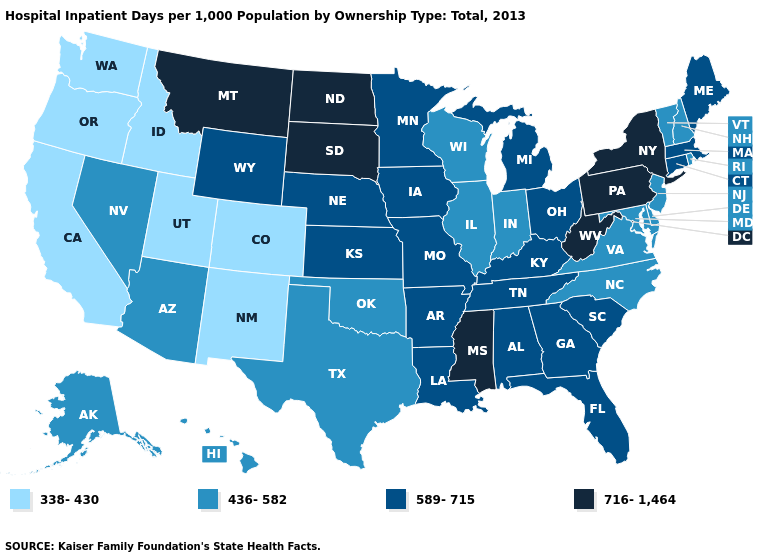Name the states that have a value in the range 716-1,464?
Answer briefly. Mississippi, Montana, New York, North Dakota, Pennsylvania, South Dakota, West Virginia. Name the states that have a value in the range 716-1,464?
Keep it brief. Mississippi, Montana, New York, North Dakota, Pennsylvania, South Dakota, West Virginia. Which states have the lowest value in the USA?
Concise answer only. California, Colorado, Idaho, New Mexico, Oregon, Utah, Washington. Does Texas have the highest value in the South?
Answer briefly. No. Name the states that have a value in the range 589-715?
Keep it brief. Alabama, Arkansas, Connecticut, Florida, Georgia, Iowa, Kansas, Kentucky, Louisiana, Maine, Massachusetts, Michigan, Minnesota, Missouri, Nebraska, Ohio, South Carolina, Tennessee, Wyoming. What is the value of New Jersey?
Write a very short answer. 436-582. Does Illinois have a higher value than Washington?
Write a very short answer. Yes. Name the states that have a value in the range 338-430?
Answer briefly. California, Colorado, Idaho, New Mexico, Oregon, Utah, Washington. Name the states that have a value in the range 338-430?
Be succinct. California, Colorado, Idaho, New Mexico, Oregon, Utah, Washington. Name the states that have a value in the range 716-1,464?
Keep it brief. Mississippi, Montana, New York, North Dakota, Pennsylvania, South Dakota, West Virginia. Is the legend a continuous bar?
Keep it brief. No. Among the states that border New Jersey , which have the lowest value?
Be succinct. Delaware. Does West Virginia have the same value as New York?
Keep it brief. Yes. Among the states that border Delaware , does New Jersey have the highest value?
Write a very short answer. No. Does the first symbol in the legend represent the smallest category?
Be succinct. Yes. 